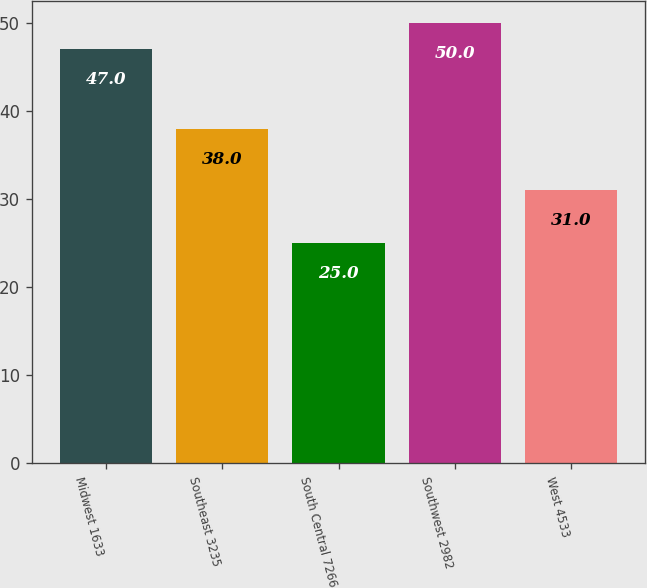<chart> <loc_0><loc_0><loc_500><loc_500><bar_chart><fcel>Midwest 1633<fcel>Southeast 3235<fcel>South Central 7266<fcel>Southwest 2982<fcel>West 4533<nl><fcel>47<fcel>38<fcel>25<fcel>50<fcel>31<nl></chart> 